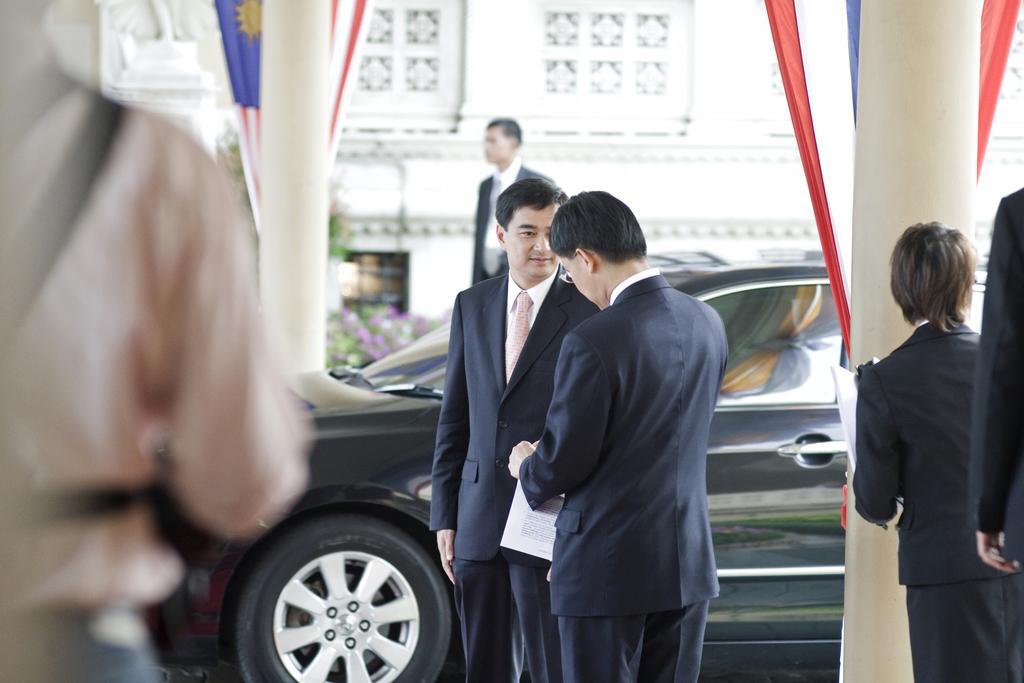Could you give a brief overview of what you see in this image? This image is taken outdoors. In the background there is a building. There are a few plants. There are two flags. On the left side of the image there is a person. In the middle of the image there are two pillars. There is a car parked on the ground. Three men are standing. On the right side of the image there are two people. 